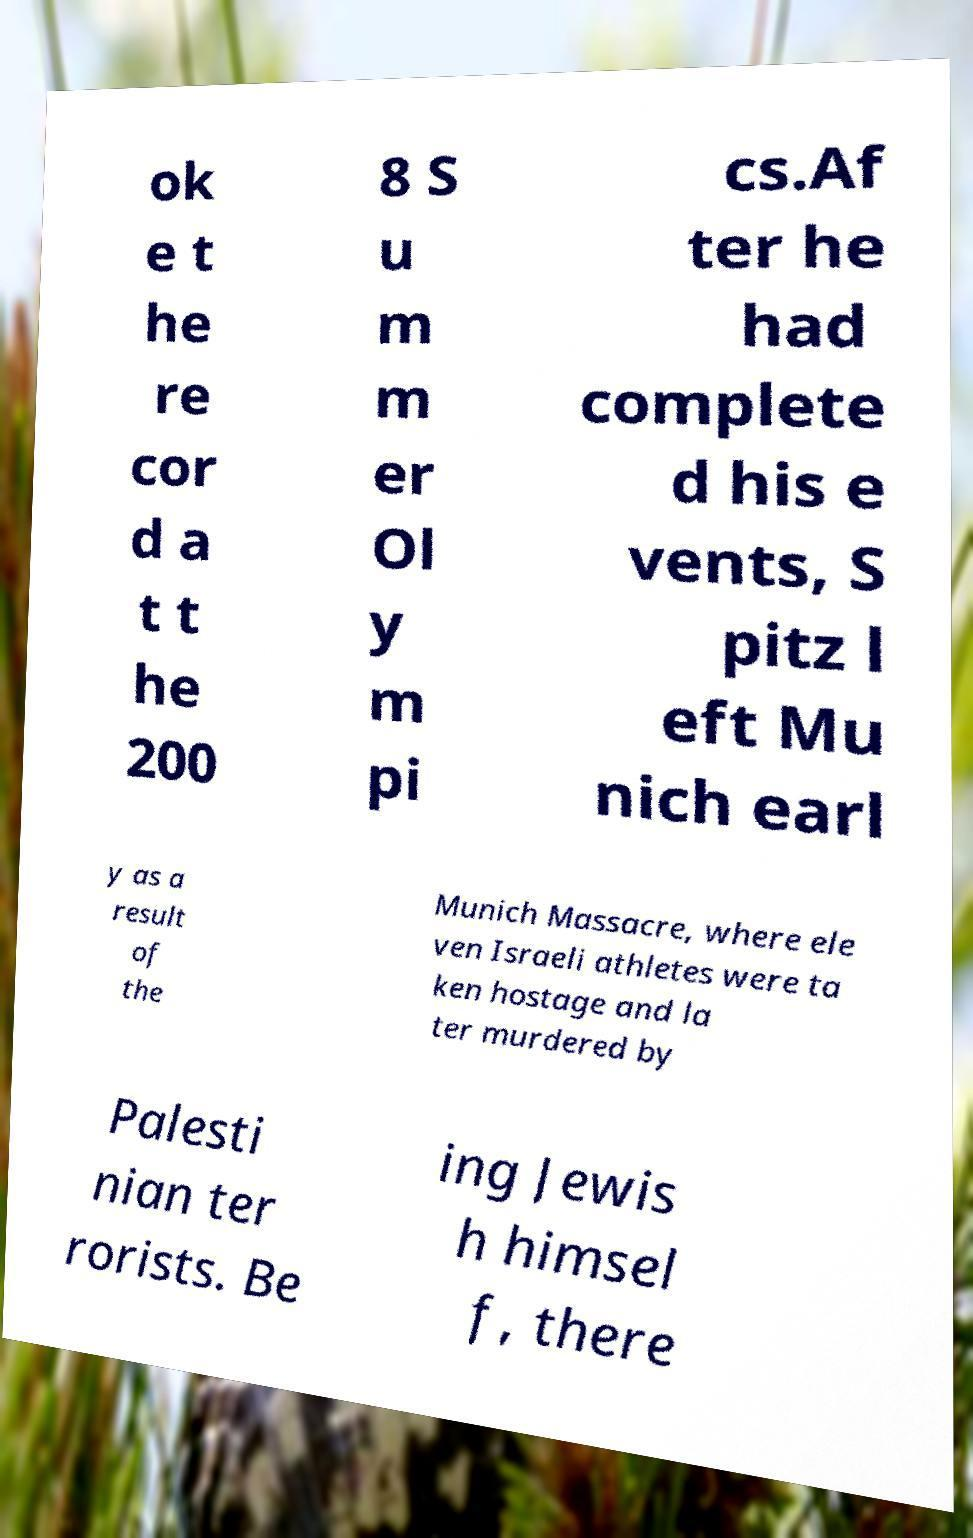I need the written content from this picture converted into text. Can you do that? ok e t he re cor d a t t he 200 8 S u m m er Ol y m pi cs.Af ter he had complete d his e vents, S pitz l eft Mu nich earl y as a result of the Munich Massacre, where ele ven Israeli athletes were ta ken hostage and la ter murdered by Palesti nian ter rorists. Be ing Jewis h himsel f, there 